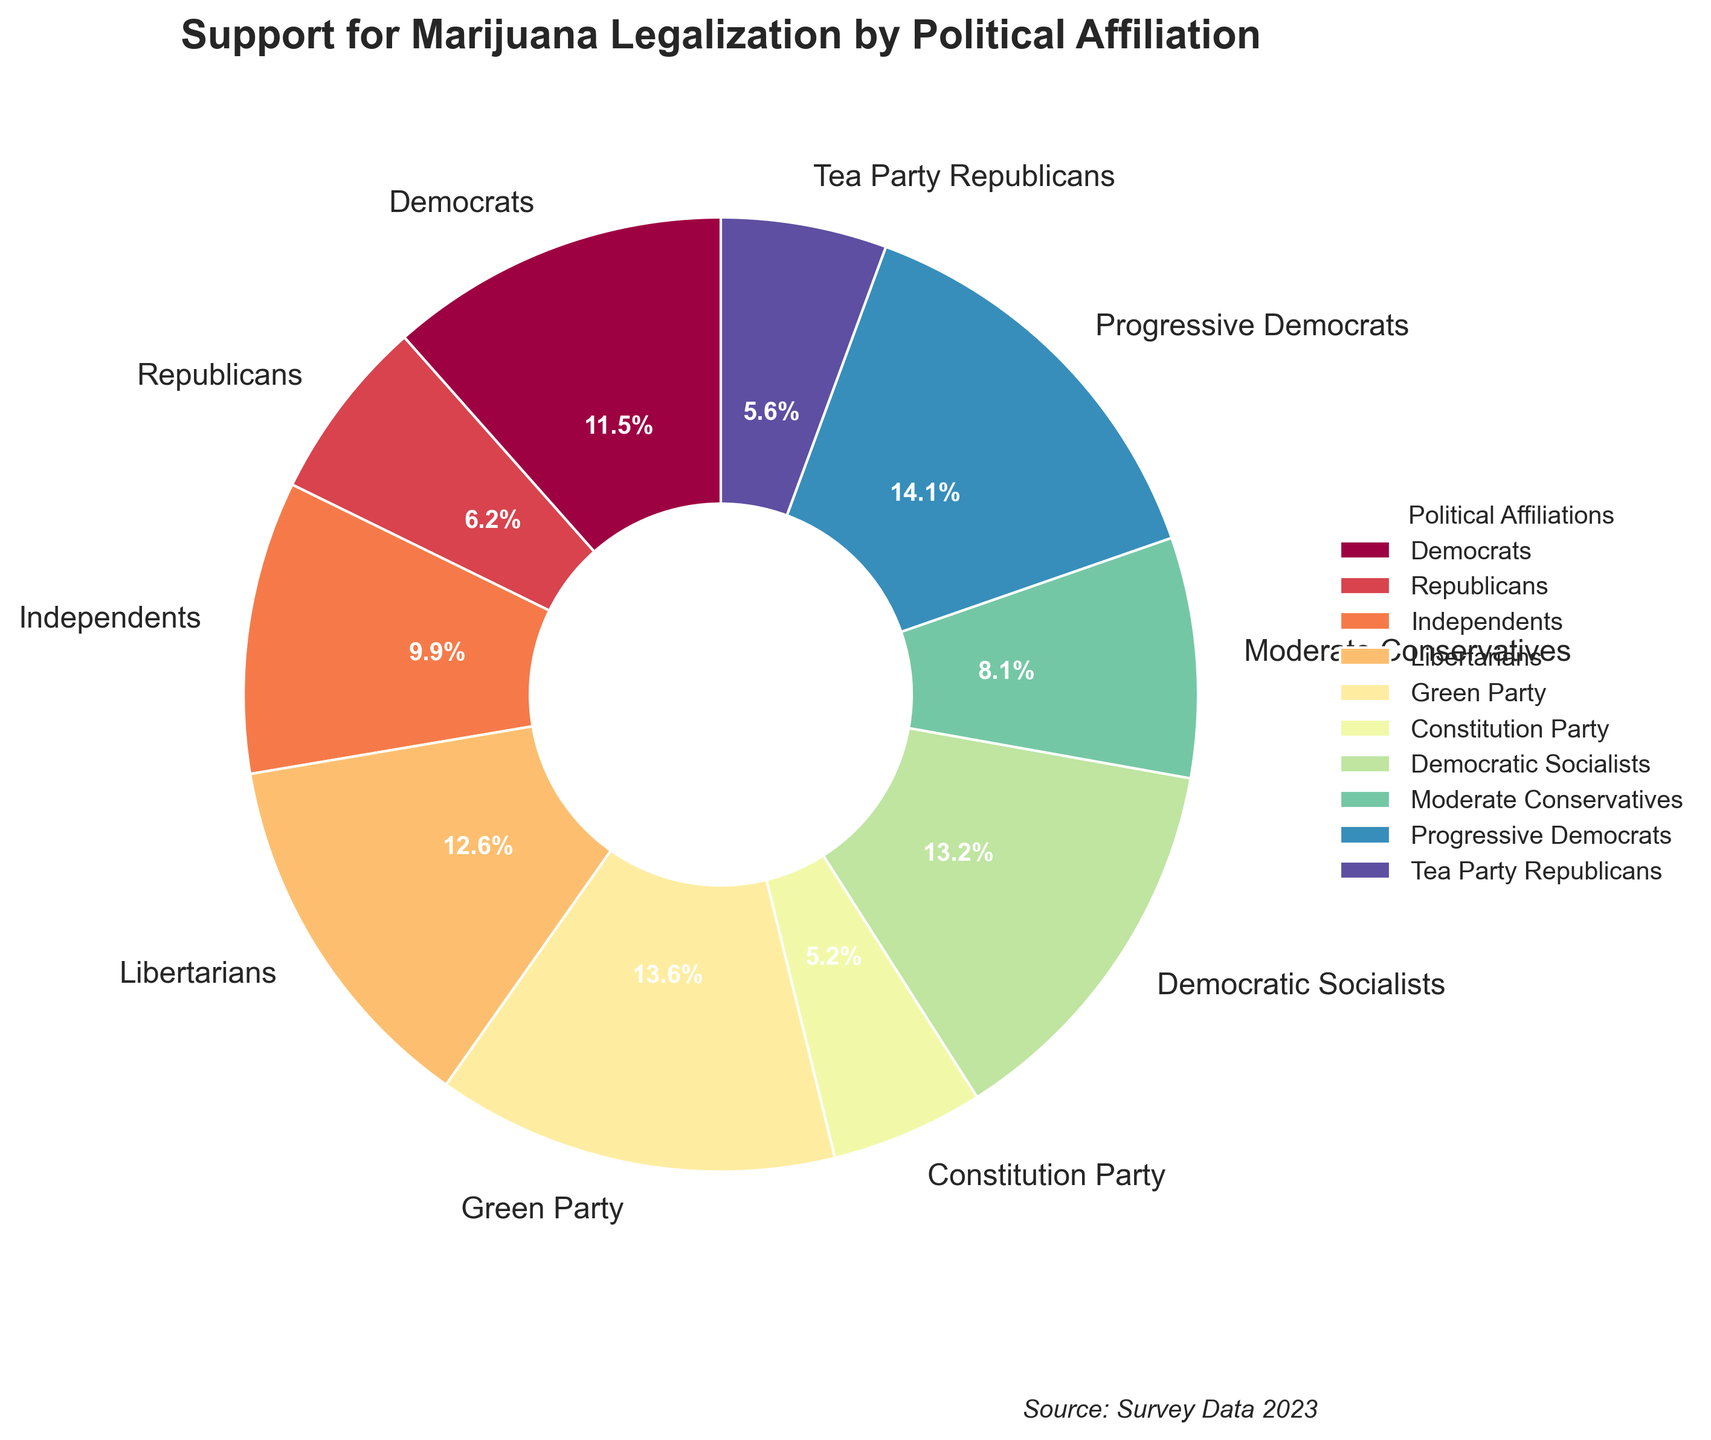Which political affiliation has the highest support for marijuana legalization? The pie chart shows different political affiliations and their respective percentages of support. Identifying the slice with the highest percentage, we see that Progressive Democrats have the highest support with 95%.
Answer: Progressive Democrats Which political affiliation has the lowest support for marijuana legalization? To find the lowest support, we locate the smallest percentage slice in the pie chart. The Constitution Party shows the lowest support at 35%.
Answer: Constitution Party Which political affiliations have support percentages greater than 70%? By examining the slices with percentages labeled, we see that Democrats (78%), Libertarians (85%), Green Party (92%), Democratic Socialists (89%), and Progressive Democrats (95%) fall into this category.
Answer: Democrats, Libertarians, Green Party, Democratic Socialists, Progressive Democrats What is the difference in support for marijuana legalization between Democrats and Republicans? Democrats have 78% support while Republicans have 42%. Subtracting these, 78% - 42% = 36%.
Answer: 36% Which group shows a support percentage closest to the average support of all groups? First, we calculate the average support: 
(78 + 42 + 67 + 85 + 92 + 35 + 89 + 55 + 95 + 38) / 10 = 67.6%. Independents show 67%, which is closest to this average.
Answer: Independents Is the support from Tea Party Republicans greater than from Moderate Conservatives? By comparing the two slices, Tea Party Republicans have 38% while Moderate Conservatives have 55%. So the support from Tea Party Republicans is less.
Answer: No How many political affiliations have support less than 50%? Identifying the slices with percentages less than 50%, we find Republicans (42%), Constitution Party (35%), and Tea Party Republicans (38%). That makes three affiliations.
Answer: 3 How much more support do Democratic Socialists have compared to Moderate Conservatives? Democratic Socialists have 89% support while Moderate Conservatives have 55%. The difference is 89% - 55% = 34%.
Answer: 34% What is the combined support percentage for Democrats, Independents, and Libertarians? Summing the percentages for these affiliations: 78% (Democrats) + 67% (Independents) + 85% (Libertarians) = 230%.
Answer: 230% Which political affiliation's support percentage appears in the darkest color segment? By examining the color gradients in the pie chart, the darkest segment corresponds to the Progressive Democrats having the highest support at 95%.
Answer: Progressive Democrats 